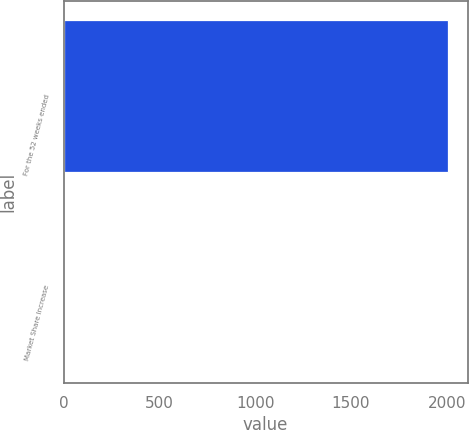Convert chart to OTSL. <chart><loc_0><loc_0><loc_500><loc_500><bar_chart><fcel>For the 52 weeks ended<fcel>Market Share Increase<nl><fcel>2009<fcel>0.1<nl></chart> 